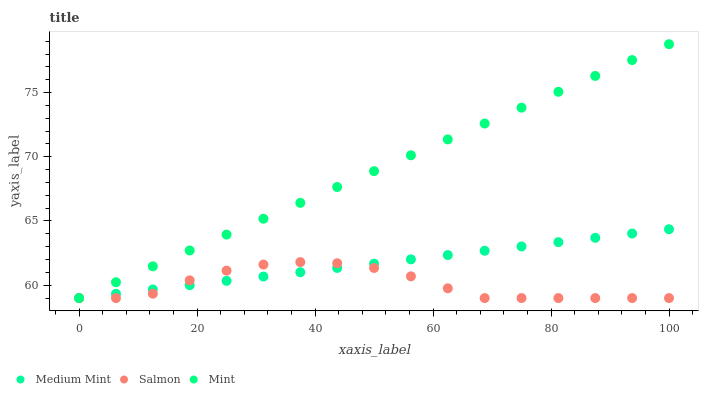Does Salmon have the minimum area under the curve?
Answer yes or no. Yes. Does Mint have the maximum area under the curve?
Answer yes or no. Yes. Does Mint have the minimum area under the curve?
Answer yes or no. No. Does Salmon have the maximum area under the curve?
Answer yes or no. No. Is Medium Mint the smoothest?
Answer yes or no. Yes. Is Salmon the roughest?
Answer yes or no. Yes. Is Mint the smoothest?
Answer yes or no. No. Is Mint the roughest?
Answer yes or no. No. Does Medium Mint have the lowest value?
Answer yes or no. Yes. Does Mint have the highest value?
Answer yes or no. Yes. Does Salmon have the highest value?
Answer yes or no. No. Does Mint intersect Salmon?
Answer yes or no. Yes. Is Mint less than Salmon?
Answer yes or no. No. Is Mint greater than Salmon?
Answer yes or no. No. 